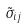<formula> <loc_0><loc_0><loc_500><loc_500>\tilde { \sigma } _ { i j }</formula> 